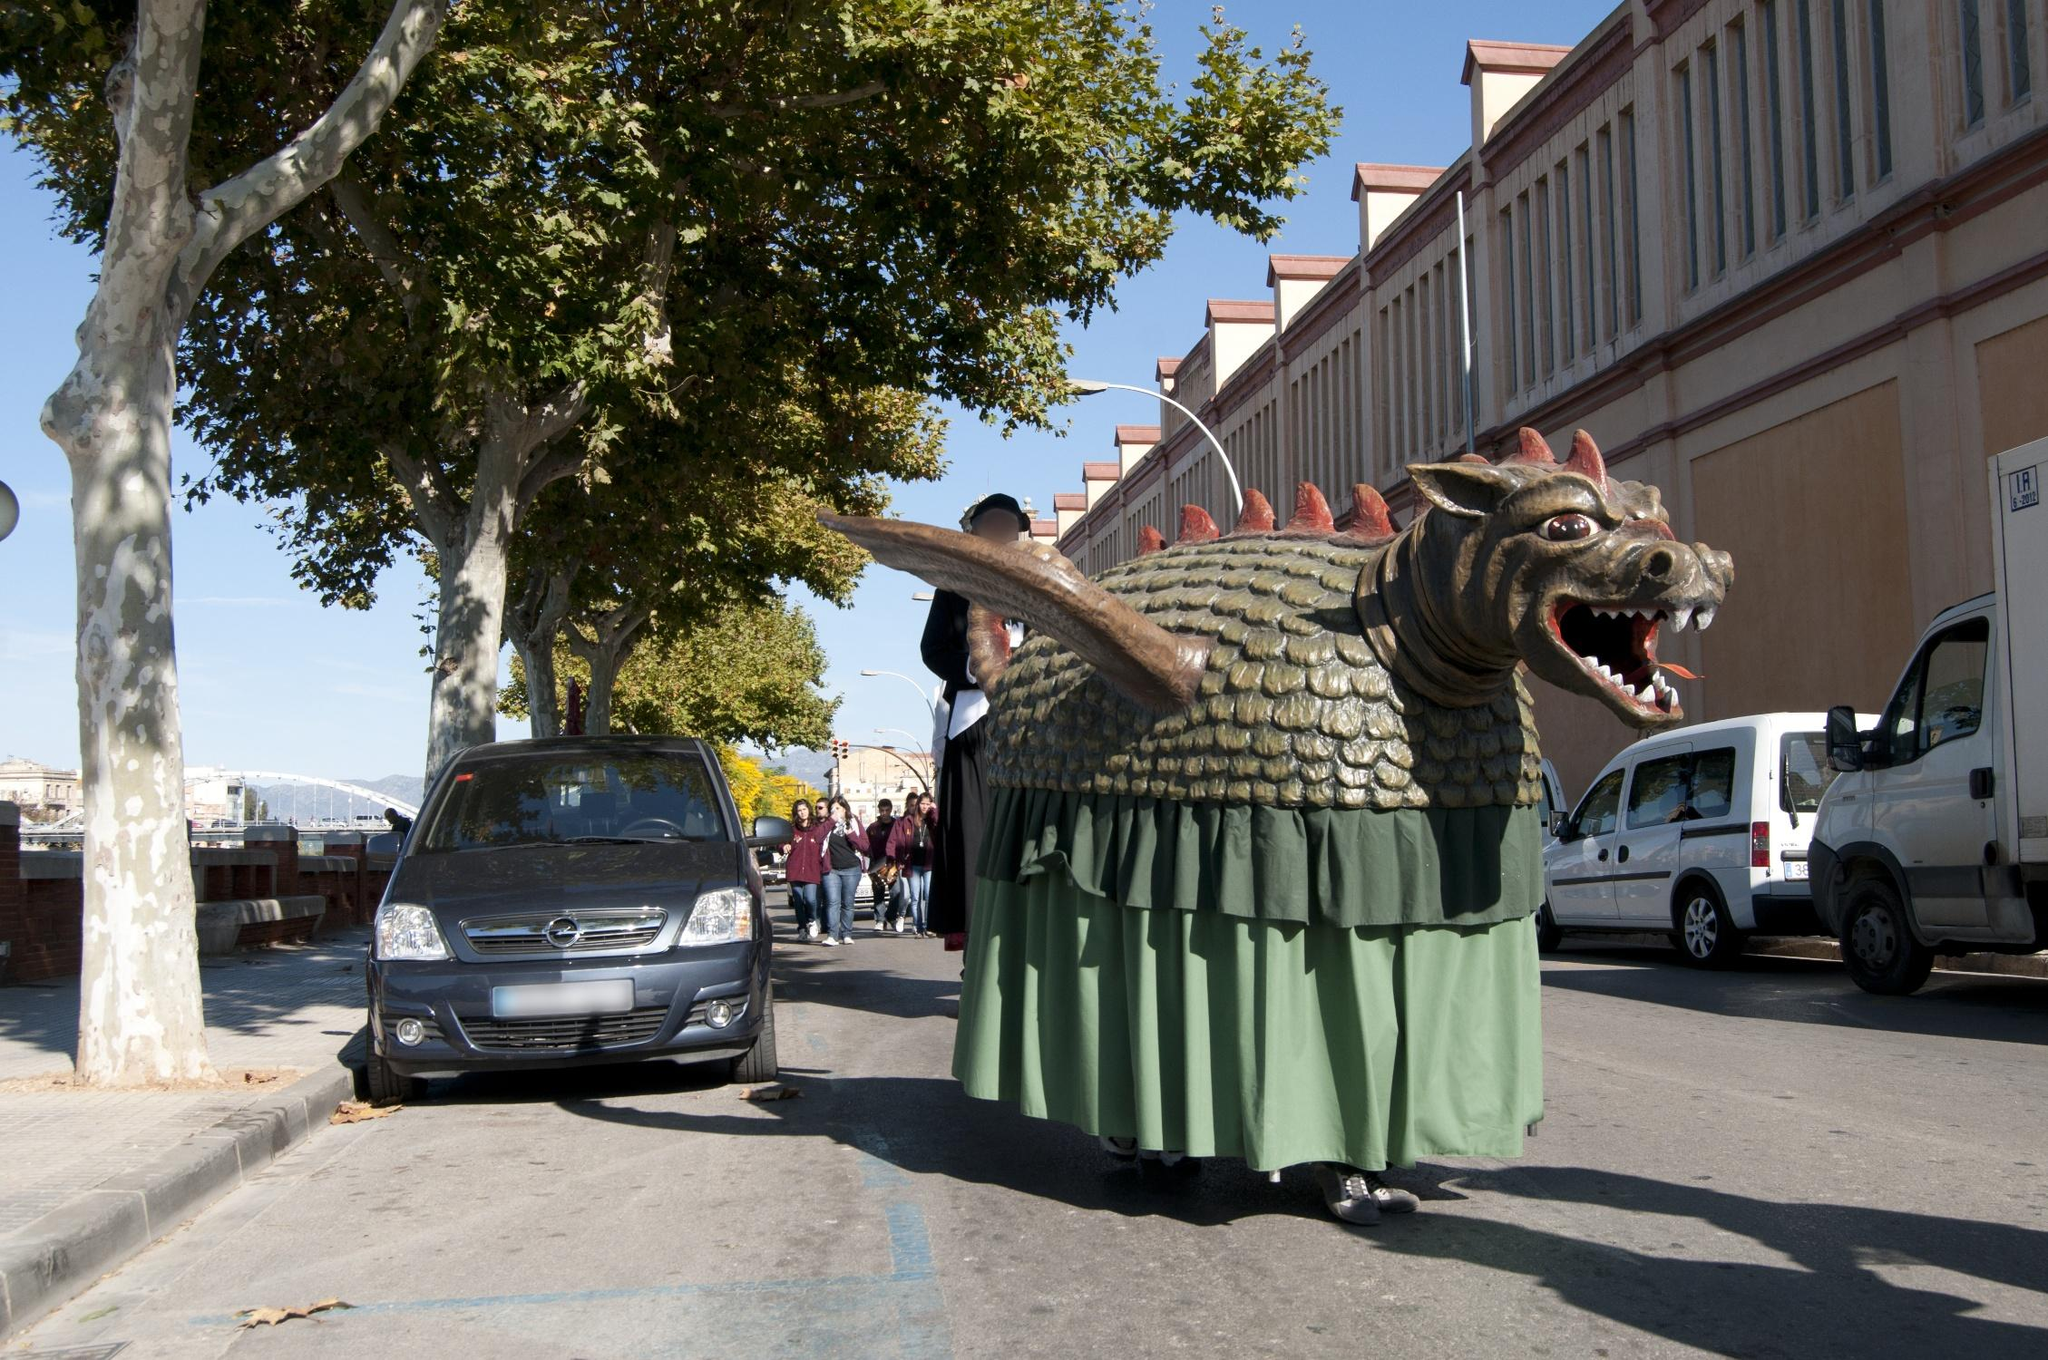Describe a realistic scenario where this image could be taken. This image could realistically be taken during La Mercè, Barcelona's annual festival held in September to honor the city's patron saint, Our Lady of Mercy. The celebration includes a variety of events such as parades, concerts, fireworks, and the famous correfoc (fire-run). The dragon float, a staple in many of these events, would be paraded down streets filled with spectators, showcasing the region's rich cultural traditions. Trees lining the street, typical urban buildings, and parked cars set the everyday backdrop against the festive spectacle, embodying the blend of daily life and traditional celebration.  What emotions might people feel when seeing this dragon in the parade? People watching the parade might experience a mix of excitement, joy, and curiosity. The enchanting and grand appearance of the dragon float could evoke a sense of nostalgia and pride in their cultural heritage. Children might feel a sense of wonder and fascination, while adults could be reminded of the significance of tradition and community spirit. The vibrant atmosphere, combined with the spectacle of the dragon, would likely create lasting and happy memories for all who witness it. 